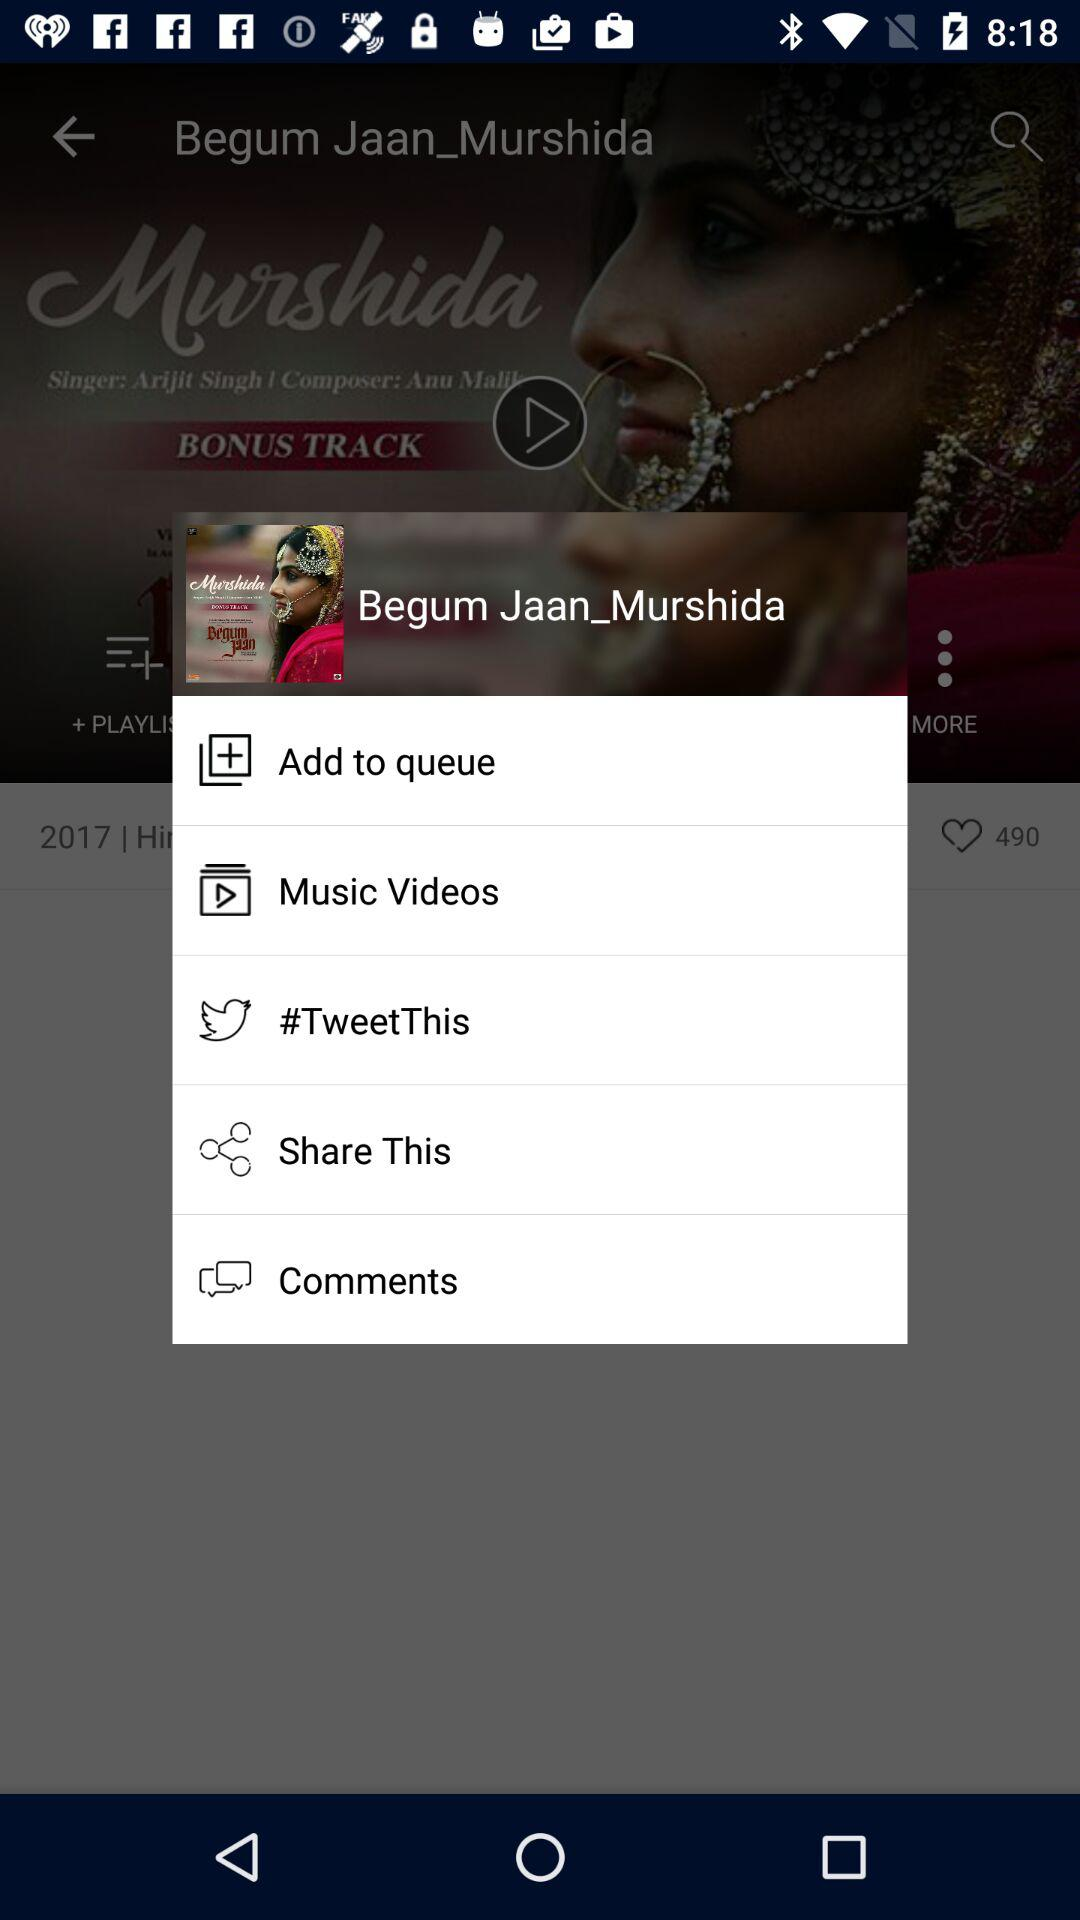What is the name of the song shown? The shown name of the song is "Murshida". 